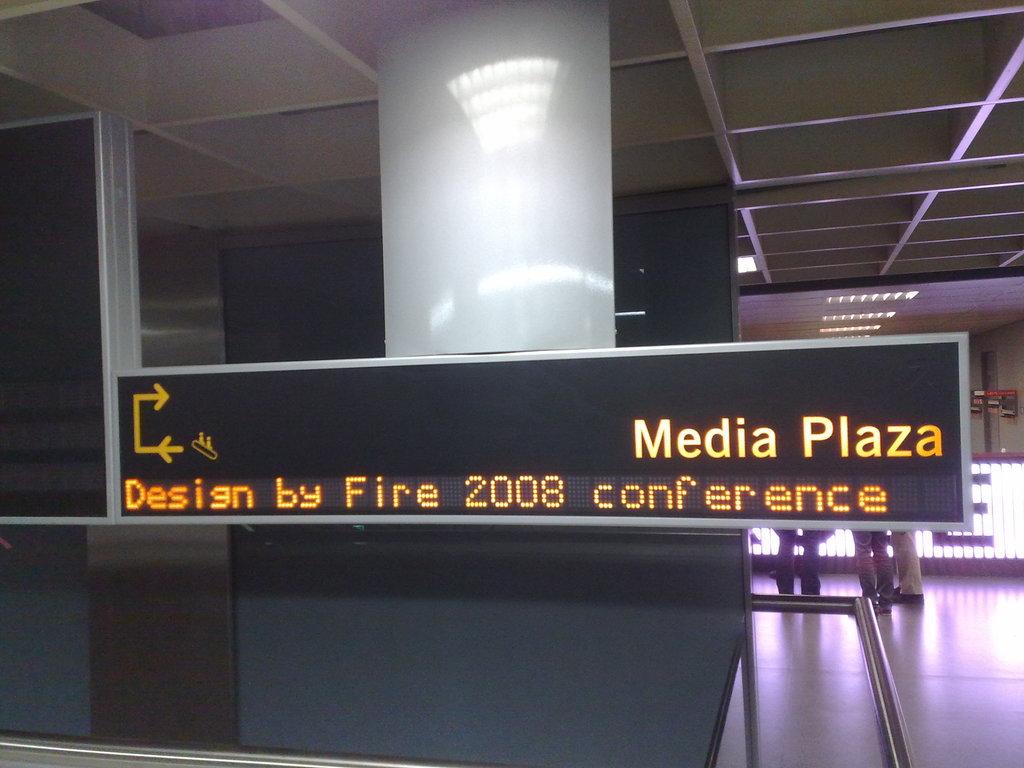What plaza is here?
Your answer should be very brief. Media. What year is mentioned on the sign?
Provide a short and direct response. 2008. 